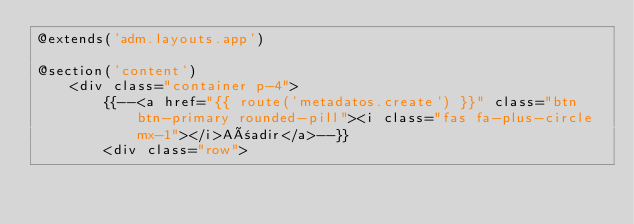<code> <loc_0><loc_0><loc_500><loc_500><_PHP_>@extends('adm.layouts.app')

@section('content')
    <div class="container p-4">
        {{--<a href="{{ route('metadatos.create') }}" class="btn btn-primary rounded-pill"><i class="fas fa-plus-circle mx-1"></i>Añadir</a>--}}
        <div class="row"></code> 